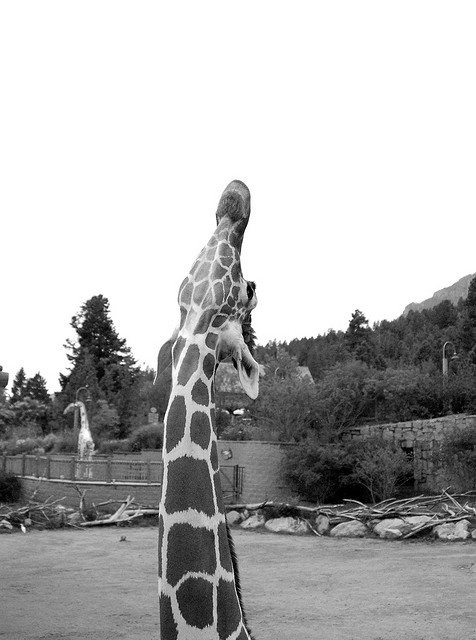Describe the objects in this image and their specific colors. I can see giraffe in white, gray, darkgray, black, and lightgray tones and giraffe in white, gray, darkgray, lightgray, and black tones in this image. 